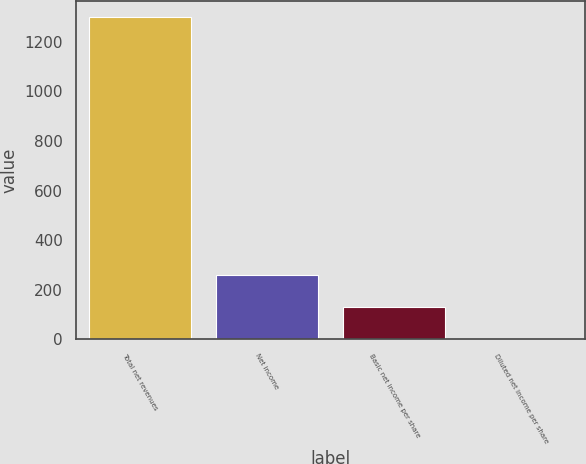Convert chart. <chart><loc_0><loc_0><loc_500><loc_500><bar_chart><fcel>Total net revenues<fcel>Net income<fcel>Basic net income per share<fcel>Diluted net income per share<nl><fcel>1299.5<fcel>260.58<fcel>130.71<fcel>0.84<nl></chart> 